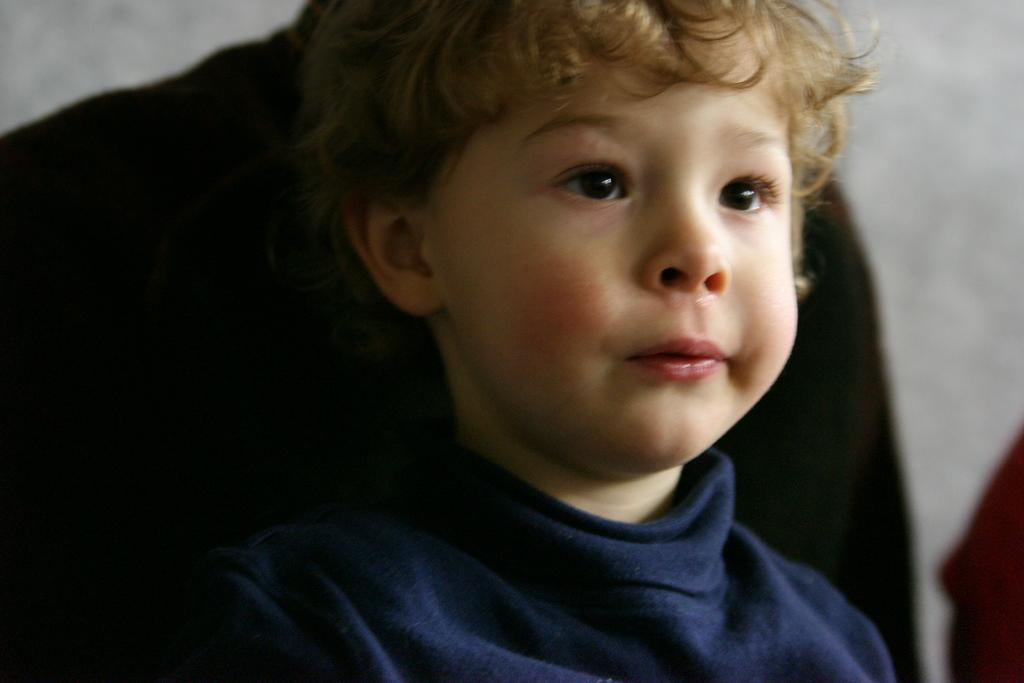Who is the main subject in the image? There is a boy in the image. What is the boy doing in the image? The boy is looking to the right side of the image. Can you describe the background of the image? The background of the image is blurred. What is the boy arguing about with his friend in the image? There is no friend present in the image, and no argument can be observed. 